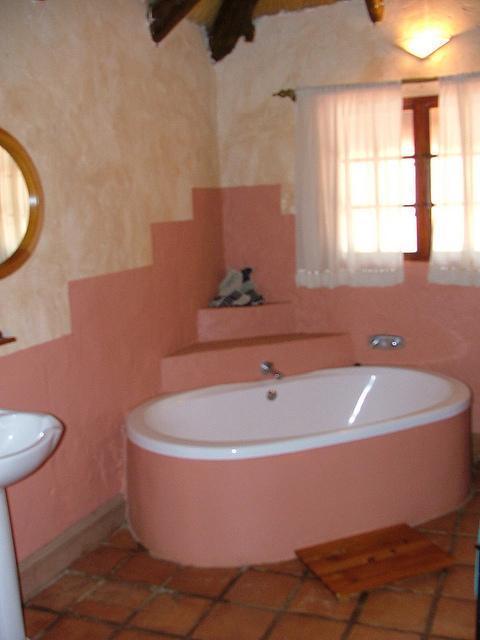How many people are holding a yellow board?
Give a very brief answer. 0. 